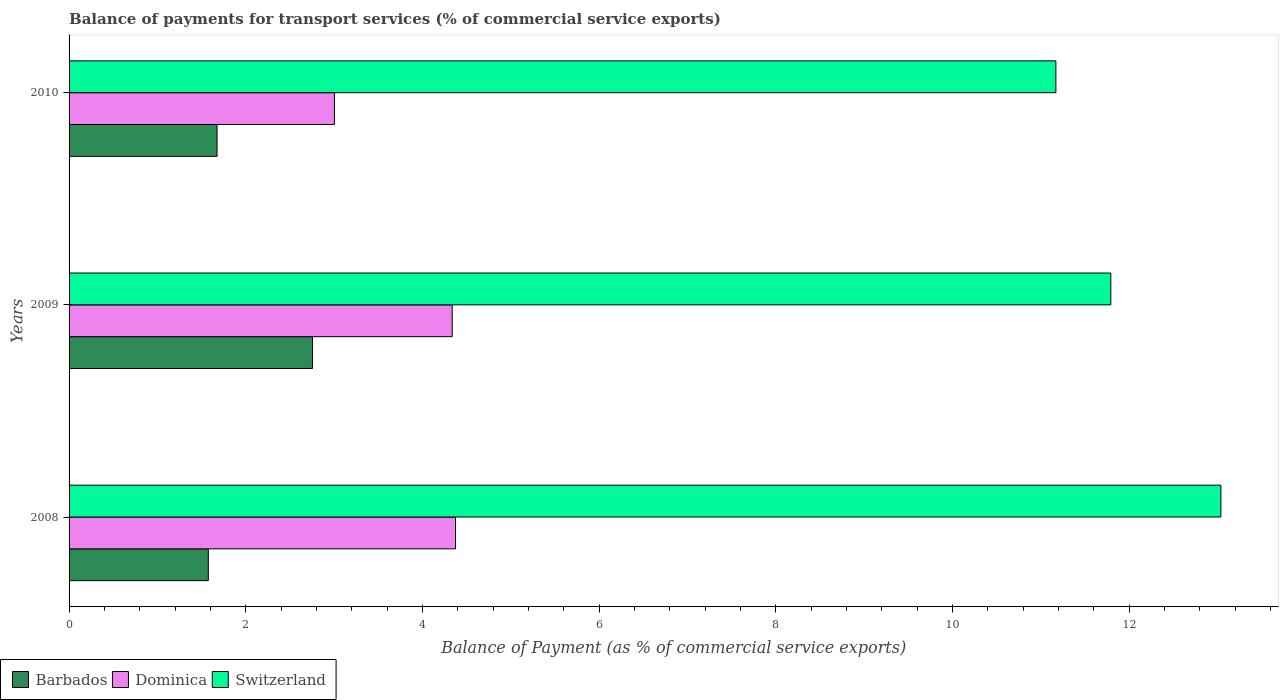How many bars are there on the 3rd tick from the bottom?
Your response must be concise. 3. What is the balance of payments for transport services in Switzerland in 2009?
Provide a succinct answer. 11.79. Across all years, what is the maximum balance of payments for transport services in Barbados?
Your answer should be compact. 2.76. Across all years, what is the minimum balance of payments for transport services in Dominica?
Ensure brevity in your answer.  3. In which year was the balance of payments for transport services in Switzerland maximum?
Your answer should be compact. 2008. In which year was the balance of payments for transport services in Barbados minimum?
Give a very brief answer. 2008. What is the total balance of payments for transport services in Dominica in the graph?
Make the answer very short. 11.72. What is the difference between the balance of payments for transport services in Barbados in 2009 and that in 2010?
Ensure brevity in your answer.  1.08. What is the difference between the balance of payments for transport services in Barbados in 2010 and the balance of payments for transport services in Switzerland in 2009?
Your answer should be very brief. -10.12. What is the average balance of payments for transport services in Barbados per year?
Provide a succinct answer. 2. In the year 2008, what is the difference between the balance of payments for transport services in Switzerland and balance of payments for transport services in Barbados?
Give a very brief answer. 11.46. What is the ratio of the balance of payments for transport services in Switzerland in 2008 to that in 2009?
Make the answer very short. 1.11. What is the difference between the highest and the second highest balance of payments for transport services in Barbados?
Offer a terse response. 1.08. What is the difference between the highest and the lowest balance of payments for transport services in Switzerland?
Offer a terse response. 1.87. What does the 1st bar from the top in 2010 represents?
Make the answer very short. Switzerland. What does the 2nd bar from the bottom in 2008 represents?
Provide a succinct answer. Dominica. Is it the case that in every year, the sum of the balance of payments for transport services in Switzerland and balance of payments for transport services in Dominica is greater than the balance of payments for transport services in Barbados?
Give a very brief answer. Yes. How many bars are there?
Make the answer very short. 9. Are all the bars in the graph horizontal?
Ensure brevity in your answer.  Yes. Are the values on the major ticks of X-axis written in scientific E-notation?
Provide a succinct answer. No. Does the graph contain grids?
Offer a very short reply. No. Where does the legend appear in the graph?
Your answer should be very brief. Bottom left. How many legend labels are there?
Provide a short and direct response. 3. How are the legend labels stacked?
Your answer should be compact. Horizontal. What is the title of the graph?
Your answer should be very brief. Balance of payments for transport services (% of commercial service exports). What is the label or title of the X-axis?
Offer a very short reply. Balance of Payment (as % of commercial service exports). What is the label or title of the Y-axis?
Your answer should be very brief. Years. What is the Balance of Payment (as % of commercial service exports) in Barbados in 2008?
Give a very brief answer. 1.58. What is the Balance of Payment (as % of commercial service exports) in Dominica in 2008?
Give a very brief answer. 4.37. What is the Balance of Payment (as % of commercial service exports) of Switzerland in 2008?
Make the answer very short. 13.04. What is the Balance of Payment (as % of commercial service exports) in Barbados in 2009?
Your response must be concise. 2.76. What is the Balance of Payment (as % of commercial service exports) of Dominica in 2009?
Your answer should be compact. 4.34. What is the Balance of Payment (as % of commercial service exports) in Switzerland in 2009?
Offer a terse response. 11.79. What is the Balance of Payment (as % of commercial service exports) in Barbados in 2010?
Your response must be concise. 1.68. What is the Balance of Payment (as % of commercial service exports) of Dominica in 2010?
Ensure brevity in your answer.  3. What is the Balance of Payment (as % of commercial service exports) in Switzerland in 2010?
Make the answer very short. 11.17. Across all years, what is the maximum Balance of Payment (as % of commercial service exports) in Barbados?
Provide a succinct answer. 2.76. Across all years, what is the maximum Balance of Payment (as % of commercial service exports) of Dominica?
Ensure brevity in your answer.  4.37. Across all years, what is the maximum Balance of Payment (as % of commercial service exports) of Switzerland?
Provide a succinct answer. 13.04. Across all years, what is the minimum Balance of Payment (as % of commercial service exports) in Barbados?
Keep it short and to the point. 1.58. Across all years, what is the minimum Balance of Payment (as % of commercial service exports) in Dominica?
Provide a short and direct response. 3. Across all years, what is the minimum Balance of Payment (as % of commercial service exports) in Switzerland?
Provide a short and direct response. 11.17. What is the total Balance of Payment (as % of commercial service exports) in Barbados in the graph?
Offer a terse response. 6.01. What is the total Balance of Payment (as % of commercial service exports) of Dominica in the graph?
Offer a terse response. 11.72. What is the total Balance of Payment (as % of commercial service exports) of Switzerland in the graph?
Your response must be concise. 36.01. What is the difference between the Balance of Payment (as % of commercial service exports) in Barbados in 2008 and that in 2009?
Keep it short and to the point. -1.18. What is the difference between the Balance of Payment (as % of commercial service exports) of Dominica in 2008 and that in 2009?
Keep it short and to the point. 0.04. What is the difference between the Balance of Payment (as % of commercial service exports) in Switzerland in 2008 and that in 2009?
Ensure brevity in your answer.  1.25. What is the difference between the Balance of Payment (as % of commercial service exports) in Barbados in 2008 and that in 2010?
Provide a succinct answer. -0.1. What is the difference between the Balance of Payment (as % of commercial service exports) of Dominica in 2008 and that in 2010?
Offer a terse response. 1.37. What is the difference between the Balance of Payment (as % of commercial service exports) of Switzerland in 2008 and that in 2010?
Your answer should be very brief. 1.87. What is the difference between the Balance of Payment (as % of commercial service exports) of Barbados in 2009 and that in 2010?
Your response must be concise. 1.08. What is the difference between the Balance of Payment (as % of commercial service exports) in Dominica in 2009 and that in 2010?
Offer a very short reply. 1.33. What is the difference between the Balance of Payment (as % of commercial service exports) of Switzerland in 2009 and that in 2010?
Provide a short and direct response. 0.62. What is the difference between the Balance of Payment (as % of commercial service exports) of Barbados in 2008 and the Balance of Payment (as % of commercial service exports) of Dominica in 2009?
Your answer should be very brief. -2.76. What is the difference between the Balance of Payment (as % of commercial service exports) in Barbados in 2008 and the Balance of Payment (as % of commercial service exports) in Switzerland in 2009?
Give a very brief answer. -10.22. What is the difference between the Balance of Payment (as % of commercial service exports) in Dominica in 2008 and the Balance of Payment (as % of commercial service exports) in Switzerland in 2009?
Offer a terse response. -7.42. What is the difference between the Balance of Payment (as % of commercial service exports) of Barbados in 2008 and the Balance of Payment (as % of commercial service exports) of Dominica in 2010?
Provide a succinct answer. -1.43. What is the difference between the Balance of Payment (as % of commercial service exports) in Barbados in 2008 and the Balance of Payment (as % of commercial service exports) in Switzerland in 2010?
Provide a short and direct response. -9.6. What is the difference between the Balance of Payment (as % of commercial service exports) of Dominica in 2008 and the Balance of Payment (as % of commercial service exports) of Switzerland in 2010?
Give a very brief answer. -6.8. What is the difference between the Balance of Payment (as % of commercial service exports) of Barbados in 2009 and the Balance of Payment (as % of commercial service exports) of Dominica in 2010?
Keep it short and to the point. -0.25. What is the difference between the Balance of Payment (as % of commercial service exports) of Barbados in 2009 and the Balance of Payment (as % of commercial service exports) of Switzerland in 2010?
Keep it short and to the point. -8.42. What is the difference between the Balance of Payment (as % of commercial service exports) in Dominica in 2009 and the Balance of Payment (as % of commercial service exports) in Switzerland in 2010?
Ensure brevity in your answer.  -6.83. What is the average Balance of Payment (as % of commercial service exports) in Barbados per year?
Give a very brief answer. 2. What is the average Balance of Payment (as % of commercial service exports) of Dominica per year?
Keep it short and to the point. 3.91. What is the average Balance of Payment (as % of commercial service exports) of Switzerland per year?
Provide a succinct answer. 12. In the year 2008, what is the difference between the Balance of Payment (as % of commercial service exports) of Barbados and Balance of Payment (as % of commercial service exports) of Dominica?
Make the answer very short. -2.8. In the year 2008, what is the difference between the Balance of Payment (as % of commercial service exports) of Barbados and Balance of Payment (as % of commercial service exports) of Switzerland?
Your response must be concise. -11.46. In the year 2008, what is the difference between the Balance of Payment (as % of commercial service exports) in Dominica and Balance of Payment (as % of commercial service exports) in Switzerland?
Provide a succinct answer. -8.67. In the year 2009, what is the difference between the Balance of Payment (as % of commercial service exports) of Barbados and Balance of Payment (as % of commercial service exports) of Dominica?
Ensure brevity in your answer.  -1.58. In the year 2009, what is the difference between the Balance of Payment (as % of commercial service exports) in Barbados and Balance of Payment (as % of commercial service exports) in Switzerland?
Give a very brief answer. -9.04. In the year 2009, what is the difference between the Balance of Payment (as % of commercial service exports) in Dominica and Balance of Payment (as % of commercial service exports) in Switzerland?
Your answer should be compact. -7.46. In the year 2010, what is the difference between the Balance of Payment (as % of commercial service exports) in Barbados and Balance of Payment (as % of commercial service exports) in Dominica?
Your answer should be compact. -1.33. In the year 2010, what is the difference between the Balance of Payment (as % of commercial service exports) in Barbados and Balance of Payment (as % of commercial service exports) in Switzerland?
Your answer should be very brief. -9.5. In the year 2010, what is the difference between the Balance of Payment (as % of commercial service exports) of Dominica and Balance of Payment (as % of commercial service exports) of Switzerland?
Your response must be concise. -8.17. What is the ratio of the Balance of Payment (as % of commercial service exports) in Barbados in 2008 to that in 2009?
Give a very brief answer. 0.57. What is the ratio of the Balance of Payment (as % of commercial service exports) in Dominica in 2008 to that in 2009?
Keep it short and to the point. 1.01. What is the ratio of the Balance of Payment (as % of commercial service exports) of Switzerland in 2008 to that in 2009?
Your answer should be compact. 1.11. What is the ratio of the Balance of Payment (as % of commercial service exports) in Barbados in 2008 to that in 2010?
Offer a terse response. 0.94. What is the ratio of the Balance of Payment (as % of commercial service exports) in Dominica in 2008 to that in 2010?
Provide a succinct answer. 1.46. What is the ratio of the Balance of Payment (as % of commercial service exports) of Switzerland in 2008 to that in 2010?
Your response must be concise. 1.17. What is the ratio of the Balance of Payment (as % of commercial service exports) of Barbados in 2009 to that in 2010?
Make the answer very short. 1.64. What is the ratio of the Balance of Payment (as % of commercial service exports) in Dominica in 2009 to that in 2010?
Ensure brevity in your answer.  1.44. What is the ratio of the Balance of Payment (as % of commercial service exports) of Switzerland in 2009 to that in 2010?
Make the answer very short. 1.06. What is the difference between the highest and the second highest Balance of Payment (as % of commercial service exports) of Barbados?
Offer a very short reply. 1.08. What is the difference between the highest and the second highest Balance of Payment (as % of commercial service exports) of Dominica?
Your answer should be very brief. 0.04. What is the difference between the highest and the second highest Balance of Payment (as % of commercial service exports) in Switzerland?
Offer a very short reply. 1.25. What is the difference between the highest and the lowest Balance of Payment (as % of commercial service exports) in Barbados?
Offer a terse response. 1.18. What is the difference between the highest and the lowest Balance of Payment (as % of commercial service exports) of Dominica?
Offer a very short reply. 1.37. What is the difference between the highest and the lowest Balance of Payment (as % of commercial service exports) in Switzerland?
Ensure brevity in your answer.  1.87. 